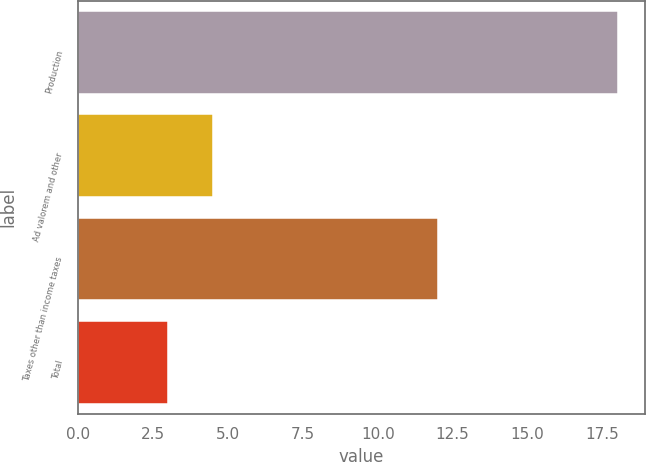Convert chart to OTSL. <chart><loc_0><loc_0><loc_500><loc_500><bar_chart><fcel>Production<fcel>Ad valorem and other<fcel>Taxes other than income taxes<fcel>Total<nl><fcel>18<fcel>4.5<fcel>12<fcel>3<nl></chart> 